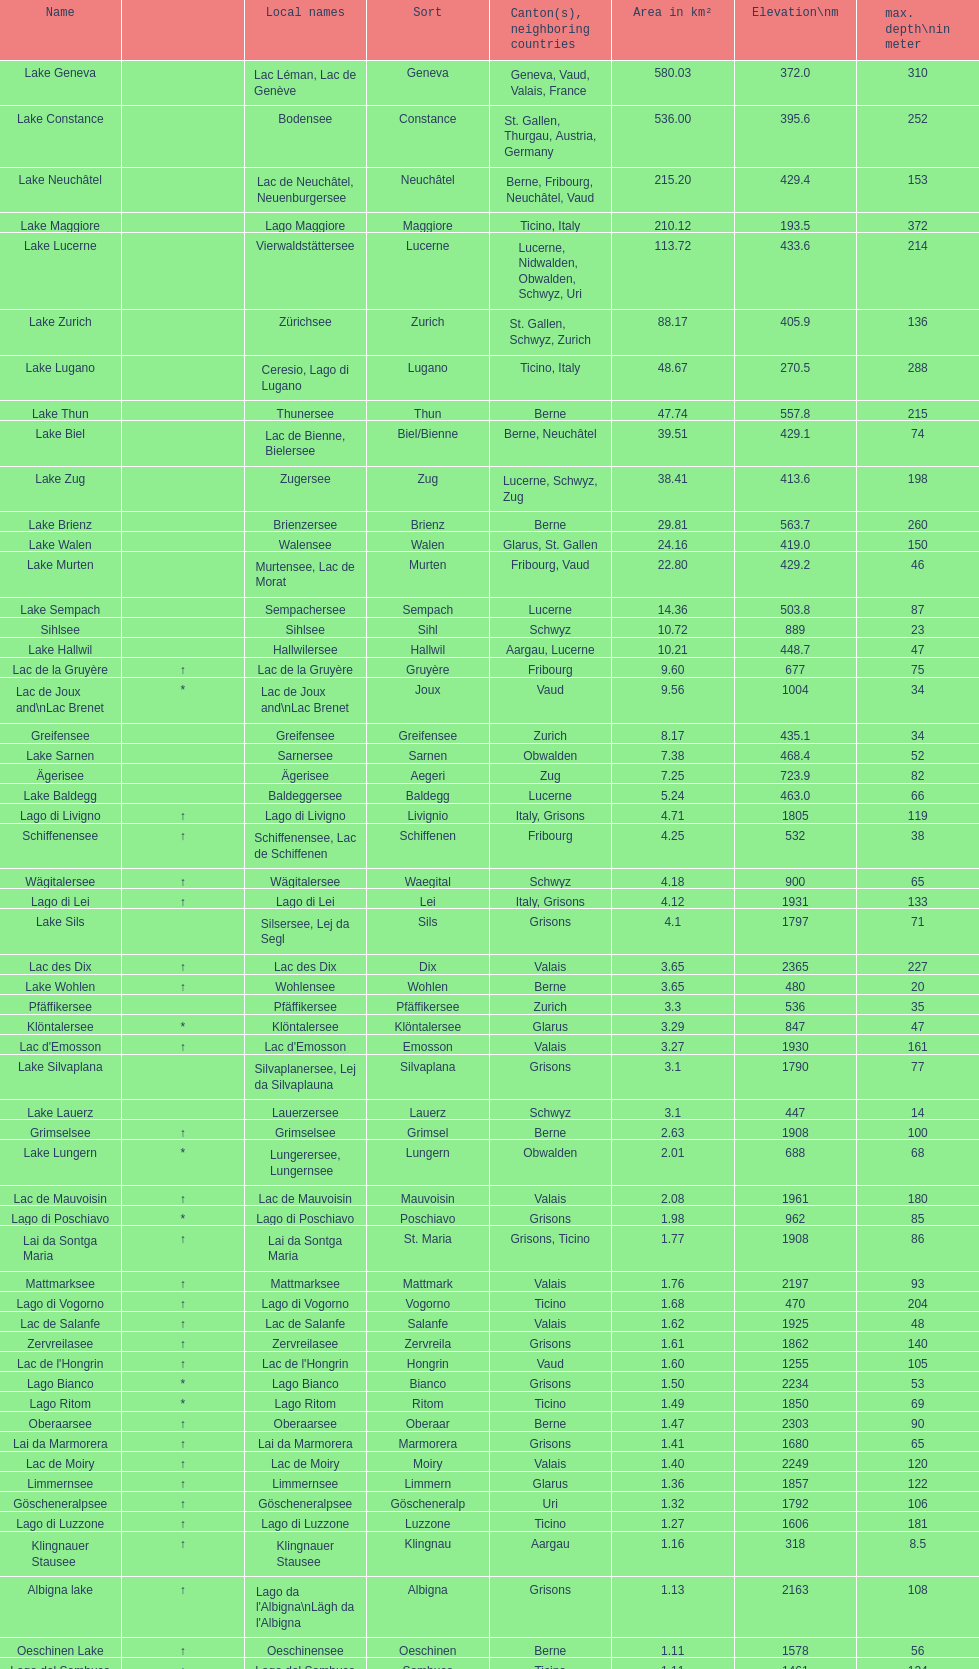Which lake has the deepest max depth? Lake Maggiore. 